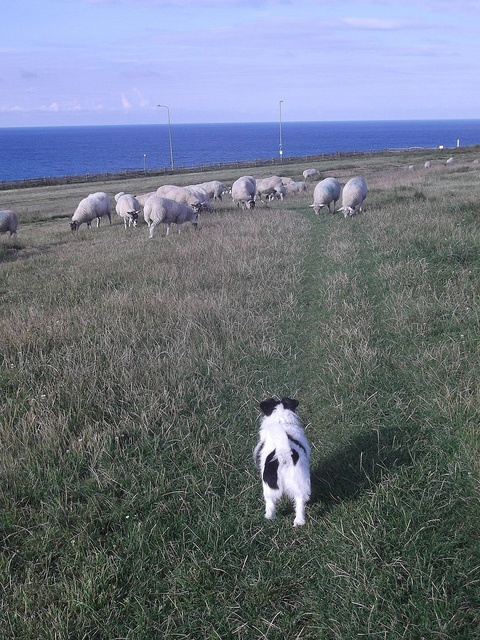Describe the objects in this image and their specific colors. I can see dog in lightblue, lavender, gray, black, and darkgray tones, sheep in lightblue, gray, darkgray, and lavender tones, sheep in lightblue, gray, and darkgray tones, sheep in lightblue, gray, darkgray, and lavender tones, and sheep in lightblue, gray, lavender, and darkgray tones in this image. 